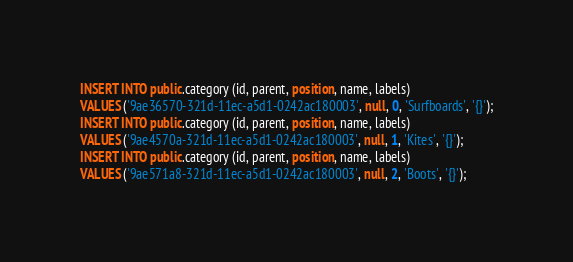Convert code to text. <code><loc_0><loc_0><loc_500><loc_500><_SQL_>INSERT INTO public.category (id, parent, position, name, labels)
VALUES ('9ae36570-321d-11ec-a5d1-0242ac180003', null, 0, 'Surfboards', '{}');
INSERT INTO public.category (id, parent, position, name, labels)
VALUES ('9ae4570a-321d-11ec-a5d1-0242ac180003', null, 1, 'Kites', '{}');
INSERT INTO public.category (id, parent, position, name, labels)
VALUES ('9ae571a8-321d-11ec-a5d1-0242ac180003', null, 2, 'Boots', '{}');
</code> 